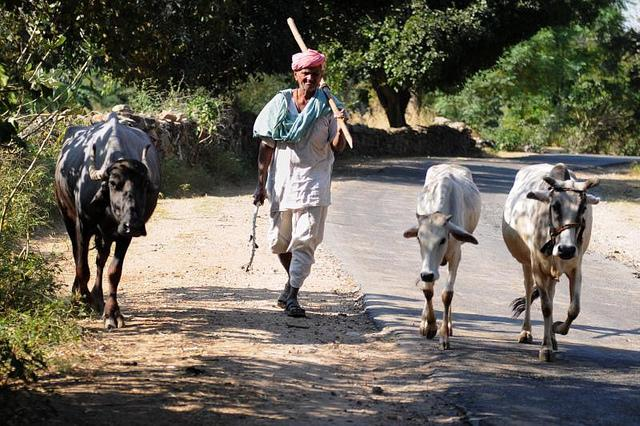How many cows are following around the man in the red turban? Please explain your reasoning. three. The man in the red turban is walking with three cows following him. 